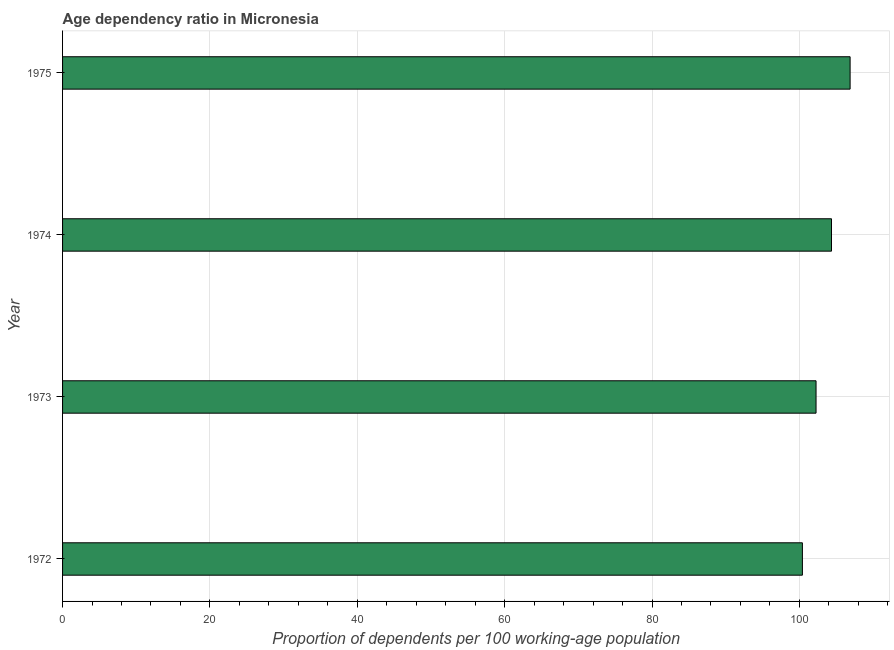Does the graph contain any zero values?
Provide a succinct answer. No. Does the graph contain grids?
Offer a very short reply. Yes. What is the title of the graph?
Keep it short and to the point. Age dependency ratio in Micronesia. What is the label or title of the X-axis?
Provide a succinct answer. Proportion of dependents per 100 working-age population. What is the age dependency ratio in 1973?
Give a very brief answer. 102.26. Across all years, what is the maximum age dependency ratio?
Make the answer very short. 106.89. Across all years, what is the minimum age dependency ratio?
Give a very brief answer. 100.41. In which year was the age dependency ratio maximum?
Offer a terse response. 1975. What is the sum of the age dependency ratio?
Offer a terse response. 413.92. What is the difference between the age dependency ratio in 1972 and 1975?
Your response must be concise. -6.47. What is the average age dependency ratio per year?
Your response must be concise. 103.48. What is the median age dependency ratio?
Keep it short and to the point. 103.31. What is the ratio of the age dependency ratio in 1973 to that in 1974?
Provide a short and direct response. 0.98. Is the age dependency ratio in 1974 less than that in 1975?
Your answer should be very brief. Yes. What is the difference between the highest and the second highest age dependency ratio?
Provide a short and direct response. 2.53. What is the difference between the highest and the lowest age dependency ratio?
Ensure brevity in your answer.  6.48. In how many years, is the age dependency ratio greater than the average age dependency ratio taken over all years?
Your response must be concise. 2. Are the values on the major ticks of X-axis written in scientific E-notation?
Offer a terse response. No. What is the Proportion of dependents per 100 working-age population of 1972?
Ensure brevity in your answer.  100.41. What is the Proportion of dependents per 100 working-age population in 1973?
Provide a succinct answer. 102.26. What is the Proportion of dependents per 100 working-age population of 1974?
Provide a succinct answer. 104.36. What is the Proportion of dependents per 100 working-age population in 1975?
Give a very brief answer. 106.89. What is the difference between the Proportion of dependents per 100 working-age population in 1972 and 1973?
Keep it short and to the point. -1.85. What is the difference between the Proportion of dependents per 100 working-age population in 1972 and 1974?
Keep it short and to the point. -3.95. What is the difference between the Proportion of dependents per 100 working-age population in 1972 and 1975?
Give a very brief answer. -6.48. What is the difference between the Proportion of dependents per 100 working-age population in 1973 and 1974?
Ensure brevity in your answer.  -2.1. What is the difference between the Proportion of dependents per 100 working-age population in 1973 and 1975?
Make the answer very short. -4.62. What is the difference between the Proportion of dependents per 100 working-age population in 1974 and 1975?
Make the answer very short. -2.53. What is the ratio of the Proportion of dependents per 100 working-age population in 1972 to that in 1973?
Provide a succinct answer. 0.98. What is the ratio of the Proportion of dependents per 100 working-age population in 1972 to that in 1975?
Give a very brief answer. 0.94. What is the ratio of the Proportion of dependents per 100 working-age population in 1973 to that in 1975?
Keep it short and to the point. 0.96. What is the ratio of the Proportion of dependents per 100 working-age population in 1974 to that in 1975?
Keep it short and to the point. 0.98. 